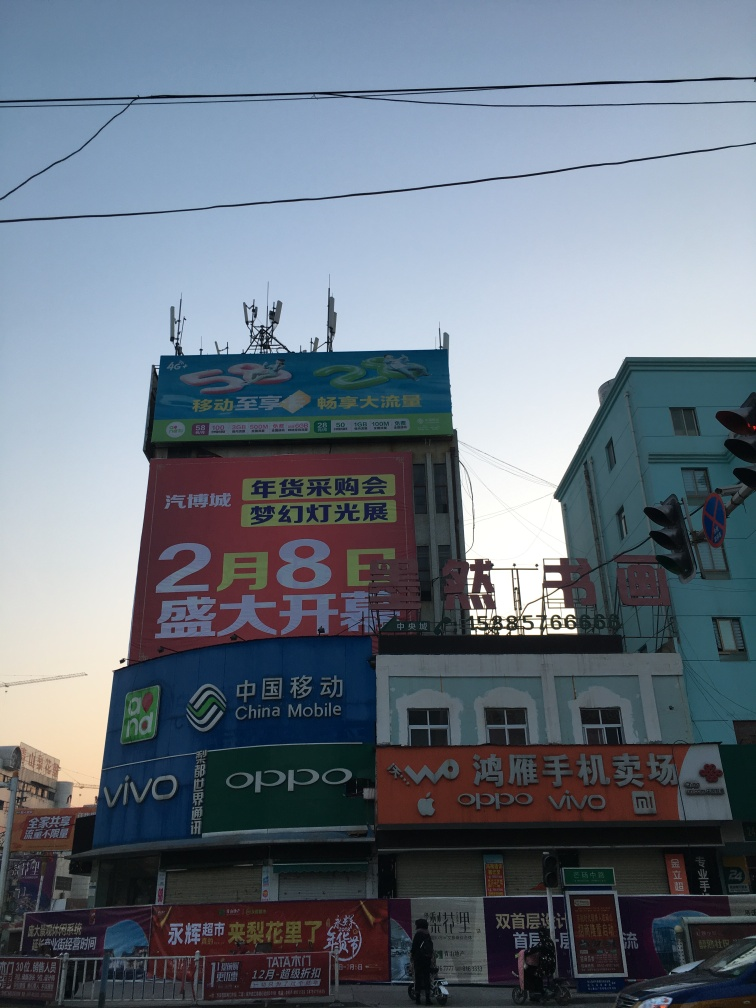Can you tell me the time of day this photo was taken? The photo appears to have been taken during the early evening, as indicated by the long shadows cast by the objects in the photo and the fading natural light in the sky. 